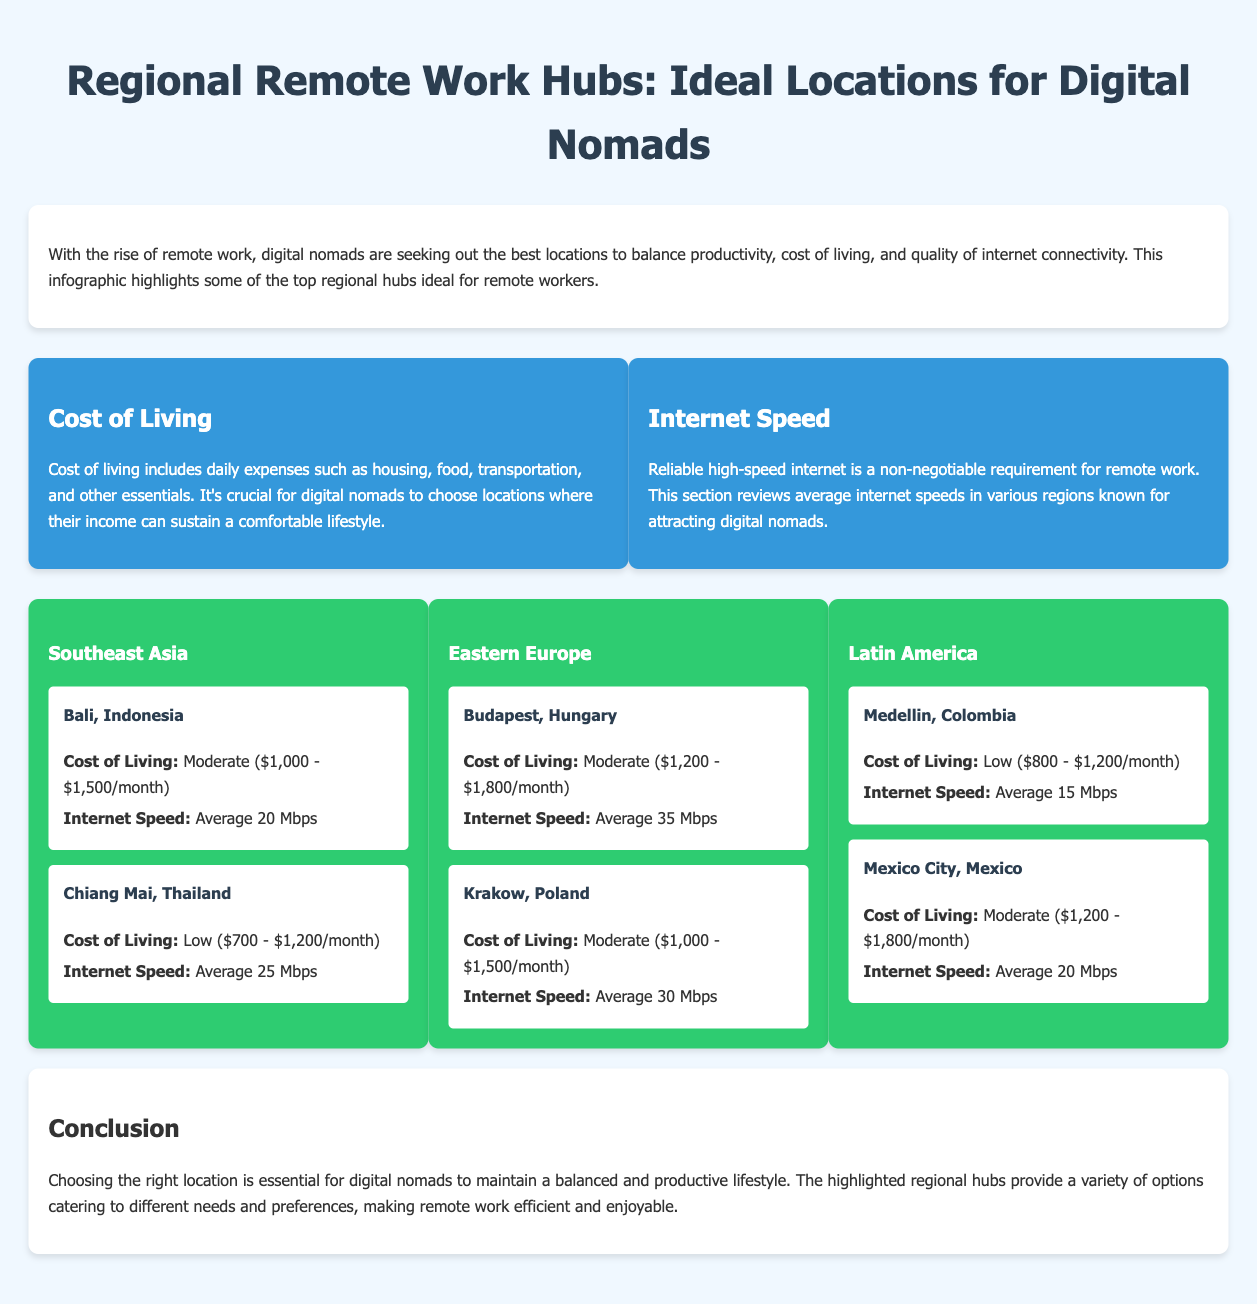What is the average cost of living in Bali? The average cost of living in Bali is specified in the document as ranging from $1,000 to $1,500 per month.
Answer: $1,000 - $1,500/month What is the internet speed in Chiang Mai? The document states that the average internet speed in Chiang Mai, Thailand is 25 Mbps.
Answer: 25 Mbps Which region has the highest average internet speed mentioned in the infographic? By comparing the locations, Budapest has the highest average internet speed listed at 35 Mbps.
Answer: Budapest What is the cost of living range for Medellin, Colombia? The document specifies that the cost of living in Medellin ranges from $800 to $1,200 per month.
Answer: $800 - $1,200/month List one key consideration for choosing a remote work hub. The document emphasizes two key considerations: cost of living and internet speed.
Answer: Cost of Living Which location has the lowest internet speed among those listed? The comparison of internet speeds indicates that Medellin, Colombia, has the lowest at 15 Mbps.
Answer: 15 Mbps What is the main focus of the infographic? The infographic focuses on showcasing ideal locations for digital nomads considering cost of living and internet speed.
Answer: Ideal locations for digital nomads Which two regions are mentioned in the Eastern Europe section? The document lists Budapest and Krakow as the two regions in Eastern Europe.
Answer: Budapest and Krakow 